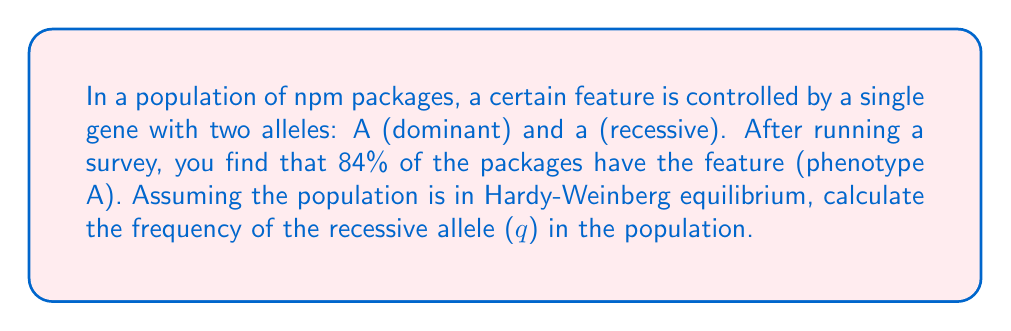Help me with this question. To solve this problem using the Hardy-Weinberg equilibrium, we'll follow these steps:

1. Recall the Hardy-Weinberg equation:
   $p^2 + 2pq + q^2 = 1$
   where $p$ is the frequency of the dominant allele (A), and $q$ is the frequency of the recessive allele (a).

2. In this case, we're given that 84% of the packages have the dominant phenotype. This includes both homozygous dominant (AA) and heterozygous (Aa) packages. The remaining 16% are homozygous recessive (aa).

3. We can express this as:
   $p^2 + 2pq = 0.84$
   $q^2 = 0.16$

4. Since $q^2 = 0.16$, we can find $q$ by taking the square root:
   $q = \sqrt{0.16} = 0.4$

5. We can verify this by calculating $p$:
   $p + q = 1$
   $p = 1 - q = 1 - 0.4 = 0.6$

6. Plugging these values back into the Hardy-Weinberg equation:
   $p^2 + 2pq + q^2 = (0.6)^2 + 2(0.6)(0.4) + (0.4)^2$
   $= 0.36 + 0.48 + 0.16 = 1$

This confirms that our calculation is correct and the population is in Hardy-Weinberg equilibrium.
Answer: The frequency of the recessive allele (q) in the population is 0.4 or 40%. 